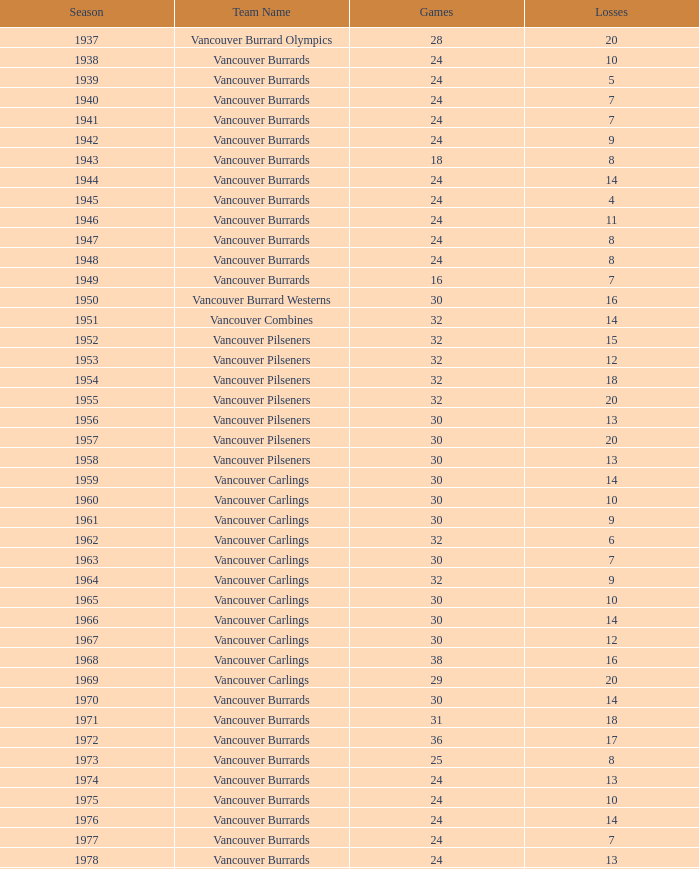What's the total number of points when the vancouver burrards have fewer than 9 losses and more than 24 games? 1.0. 